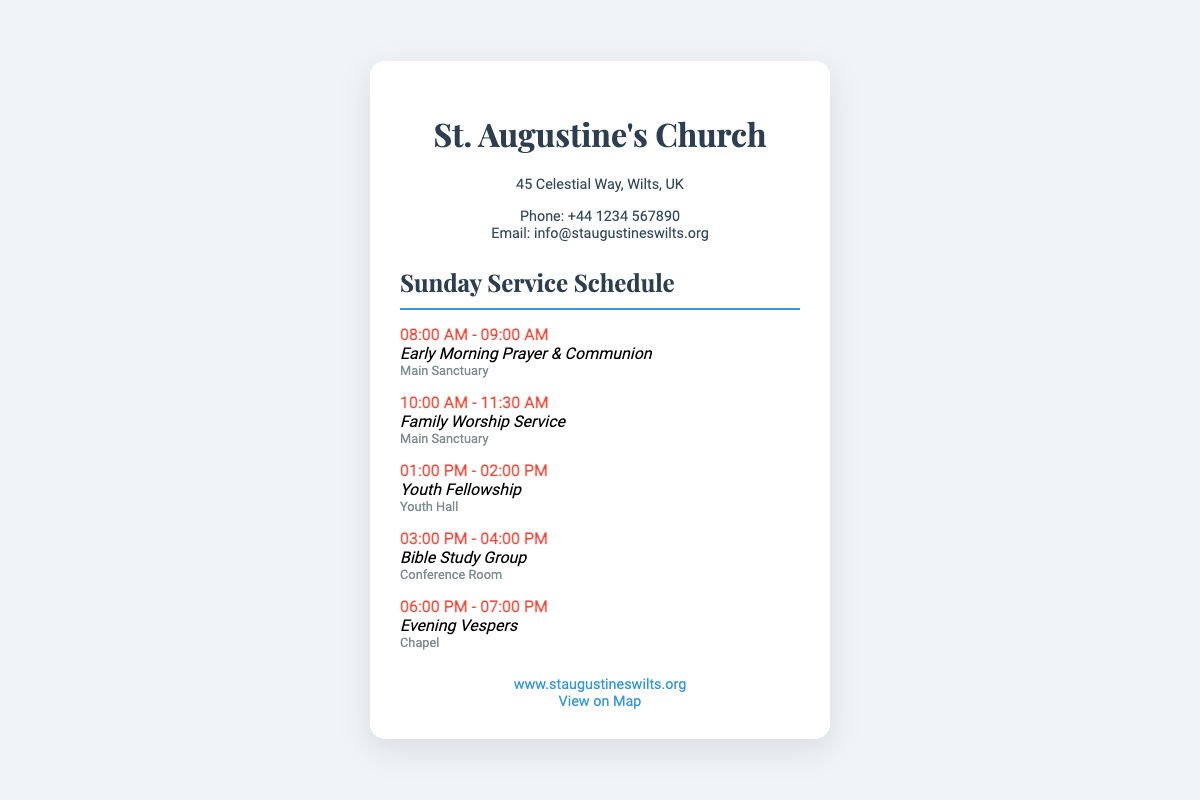What is the address of St. Augustine's Church? The address is mentioned in the contact section of the document.
Answer: 45 Celestial Way, Wilts, UK What time does the Family Worship Service start? The start time for the Family Worship Service is listed in the Sunday Service Schedule.
Answer: 10:00 AM What is the location for the Evening Vespers? The location for Evening Vespers is mentioned in the service details.
Answer: Chapel How long is the Bible Study Group session? The duration is specified in the schedule for that service.
Answer: 1 hour What is the phone number for the church? The phone number is provided in the contact information section.
Answer: +44 1234 567890 Which service is held in the Youth Hall? The service location is noted next to the service name in the schedule.
Answer: Youth Fellowship How many services are listed in the Sunday Service Schedule? The total number of services can be counted from the schedule section.
Answer: 5 What is the URL for the church's website? The website link is included in the additional information section.
Answer: www.staugustineswilts.org What time does the Early Morning Prayer & Communion end? The end time for that service is noted in the schedule.
Answer: 09:00 AM 